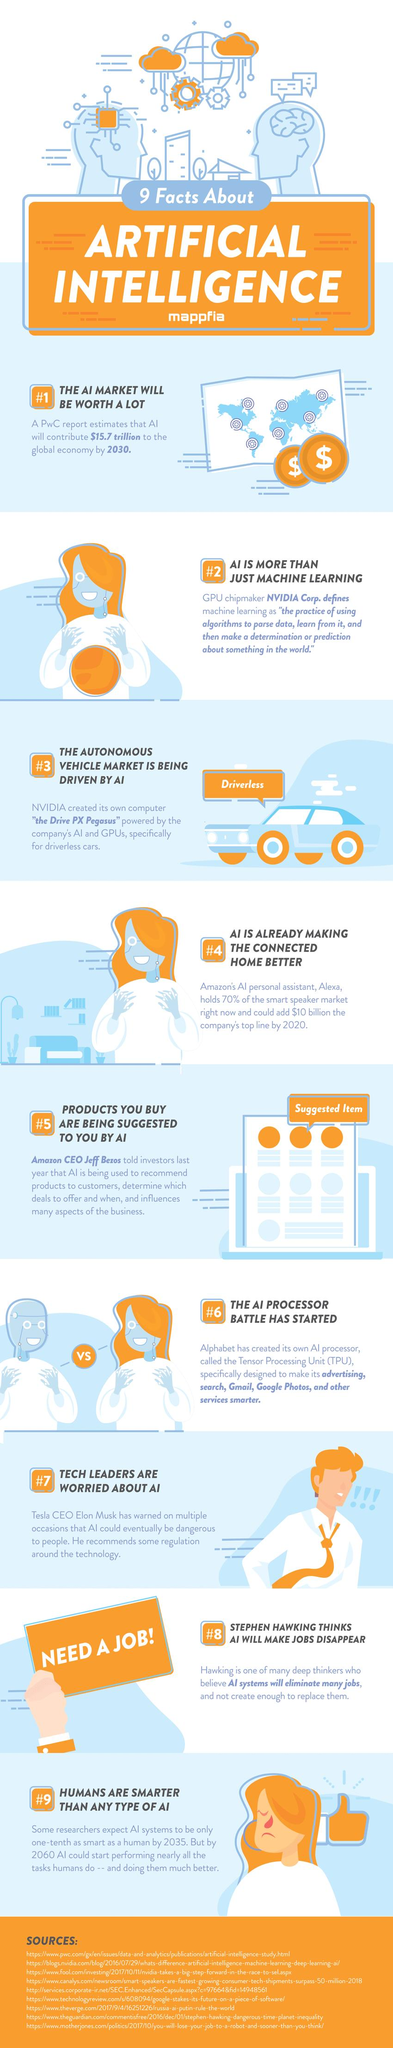Give some essential details in this illustration. Elon Musk, a prominent tech leader, believes that AI has the potential to pose a significant danger to society in the future. The CEO of Tesla believes that artificial intelligence poses a danger. The CEO of a company stated that AI has the potential to generate product recommendations. Amazon was mentioned as the specific company. Artificial intelligence is predicted to result in fewer jobs, as it has the potential to automate many tasks that are currently performed by humans. According to a recent estimate, the AI market is projected to reach a staggering $15.7 trillion in the next 10 years. 